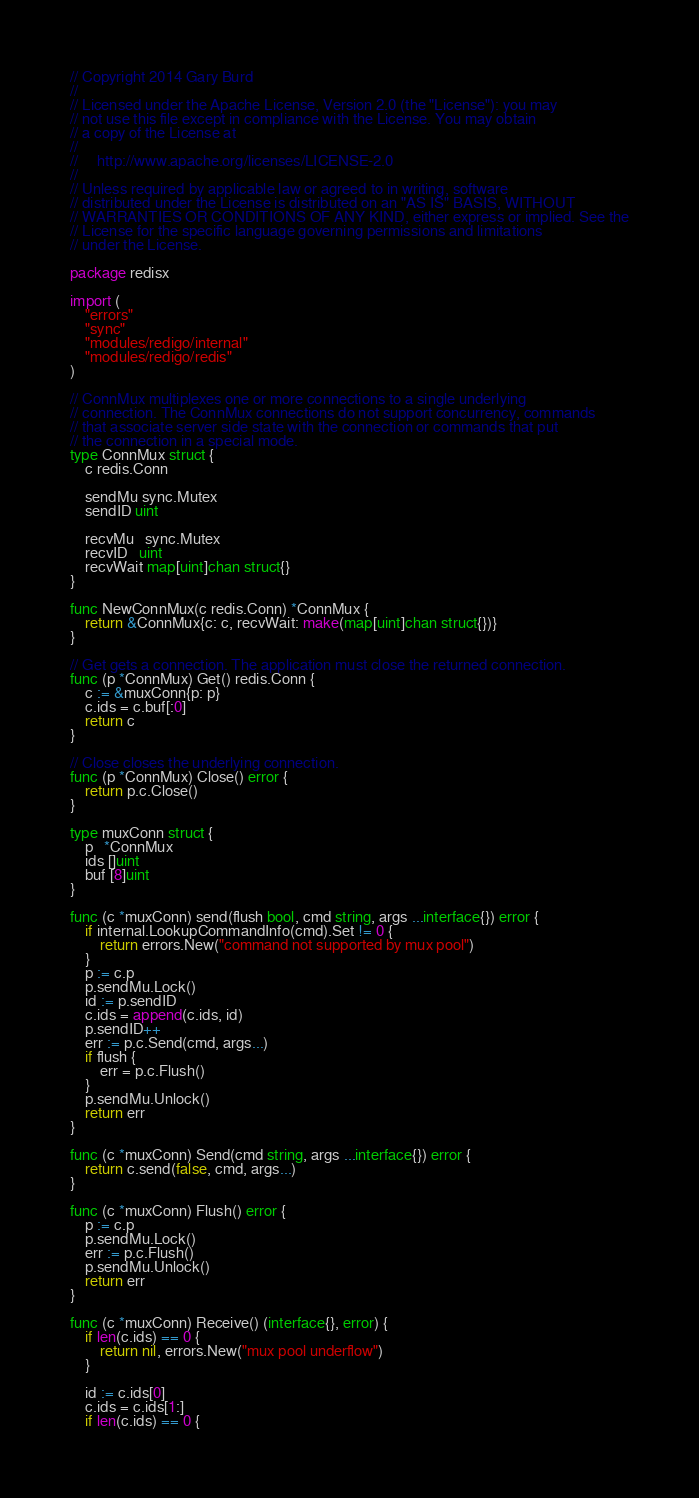<code> <loc_0><loc_0><loc_500><loc_500><_Go_>// Copyright 2014 Gary Burd
//
// Licensed under the Apache License, Version 2.0 (the "License"): you may
// not use this file except in compliance with the License. You may obtain
// a copy of the License at
//
//     http://www.apache.org/licenses/LICENSE-2.0
//
// Unless required by applicable law or agreed to in writing, software
// distributed under the License is distributed on an "AS IS" BASIS, WITHOUT
// WARRANTIES OR CONDITIONS OF ANY KIND, either express or implied. See the
// License for the specific language governing permissions and limitations
// under the License.

package redisx

import (
	"errors"
	"sync"
	"modules/redigo/internal"
	"modules/redigo/redis"
)

// ConnMux multiplexes one or more connections to a single underlying
// connection. The ConnMux connections do not support concurrency, commands
// that associate server side state with the connection or commands that put
// the connection in a special mode.
type ConnMux struct {
	c redis.Conn

	sendMu sync.Mutex
	sendID uint

	recvMu   sync.Mutex
	recvID   uint
	recvWait map[uint]chan struct{}
}

func NewConnMux(c redis.Conn) *ConnMux {
	return &ConnMux{c: c, recvWait: make(map[uint]chan struct{})}
}

// Get gets a connection. The application must close the returned connection.
func (p *ConnMux) Get() redis.Conn {
	c := &muxConn{p: p}
	c.ids = c.buf[:0]
	return c
}

// Close closes the underlying connection.
func (p *ConnMux) Close() error {
	return p.c.Close()
}

type muxConn struct {
	p   *ConnMux
	ids []uint
	buf [8]uint
}

func (c *muxConn) send(flush bool, cmd string, args ...interface{}) error {
	if internal.LookupCommandInfo(cmd).Set != 0 {
		return errors.New("command not supported by mux pool")
	}
	p := c.p
	p.sendMu.Lock()
	id := p.sendID
	c.ids = append(c.ids, id)
	p.sendID++
	err := p.c.Send(cmd, args...)
	if flush {
		err = p.c.Flush()
	}
	p.sendMu.Unlock()
	return err
}

func (c *muxConn) Send(cmd string, args ...interface{}) error {
	return c.send(false, cmd, args...)
}

func (c *muxConn) Flush() error {
	p := c.p
	p.sendMu.Lock()
	err := p.c.Flush()
	p.sendMu.Unlock()
	return err
}

func (c *muxConn) Receive() (interface{}, error) {
	if len(c.ids) == 0 {
		return nil, errors.New("mux pool underflow")
	}

	id := c.ids[0]
	c.ids = c.ids[1:]
	if len(c.ids) == 0 {</code> 